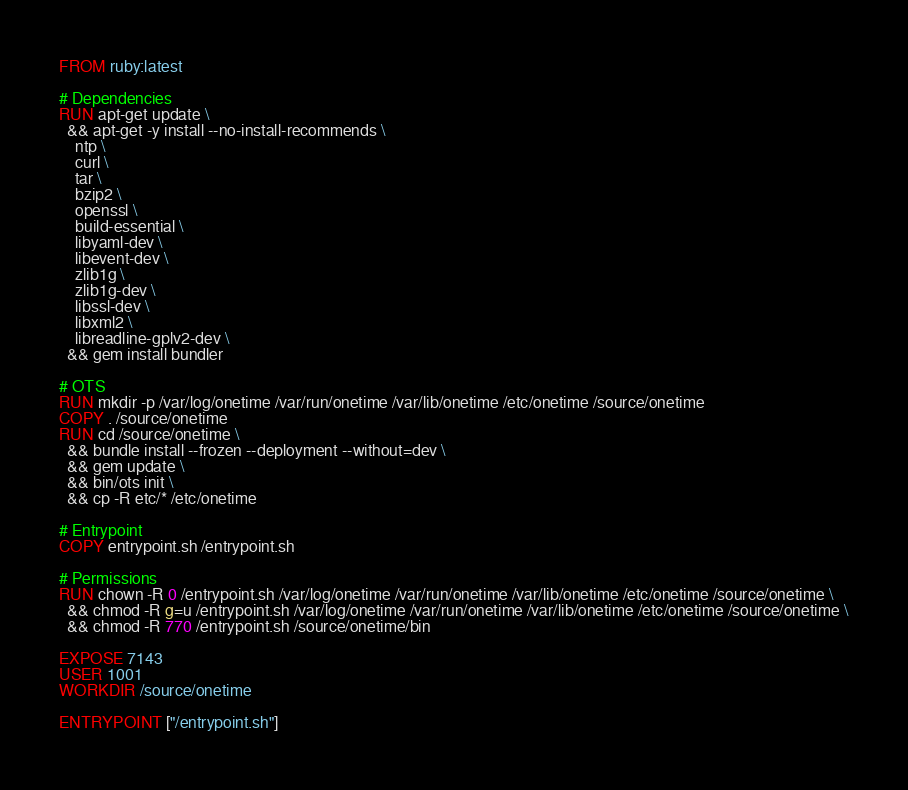Convert code to text. <code><loc_0><loc_0><loc_500><loc_500><_Dockerfile_>FROM ruby:latest

# Dependencies
RUN apt-get update \
  && apt-get -y install --no-install-recommends \
    ntp \
    curl \
    tar \
    bzip2 \
    openssl \
    build-essential \
    libyaml-dev \
    libevent-dev \
    zlib1g \
    zlib1g-dev \
    libssl-dev \
    libxml2 \
    libreadline-gplv2-dev \
  && gem install bundler

# OTS
RUN mkdir -p /var/log/onetime /var/run/onetime /var/lib/onetime /etc/onetime /source/onetime
COPY . /source/onetime
RUN cd /source/onetime \
  && bundle install --frozen --deployment --without=dev \
  && gem update \
  && bin/ots init \
  && cp -R etc/* /etc/onetime

# Entrypoint
COPY entrypoint.sh /entrypoint.sh

# Permissions
RUN chown -R 0 /entrypoint.sh /var/log/onetime /var/run/onetime /var/lib/onetime /etc/onetime /source/onetime \
  && chmod -R g=u /entrypoint.sh /var/log/onetime /var/run/onetime /var/lib/onetime /etc/onetime /source/onetime \
  && chmod -R 770 /entrypoint.sh /source/onetime/bin

EXPOSE 7143
USER 1001
WORKDIR /source/onetime

ENTRYPOINT ["/entrypoint.sh"]
</code> 